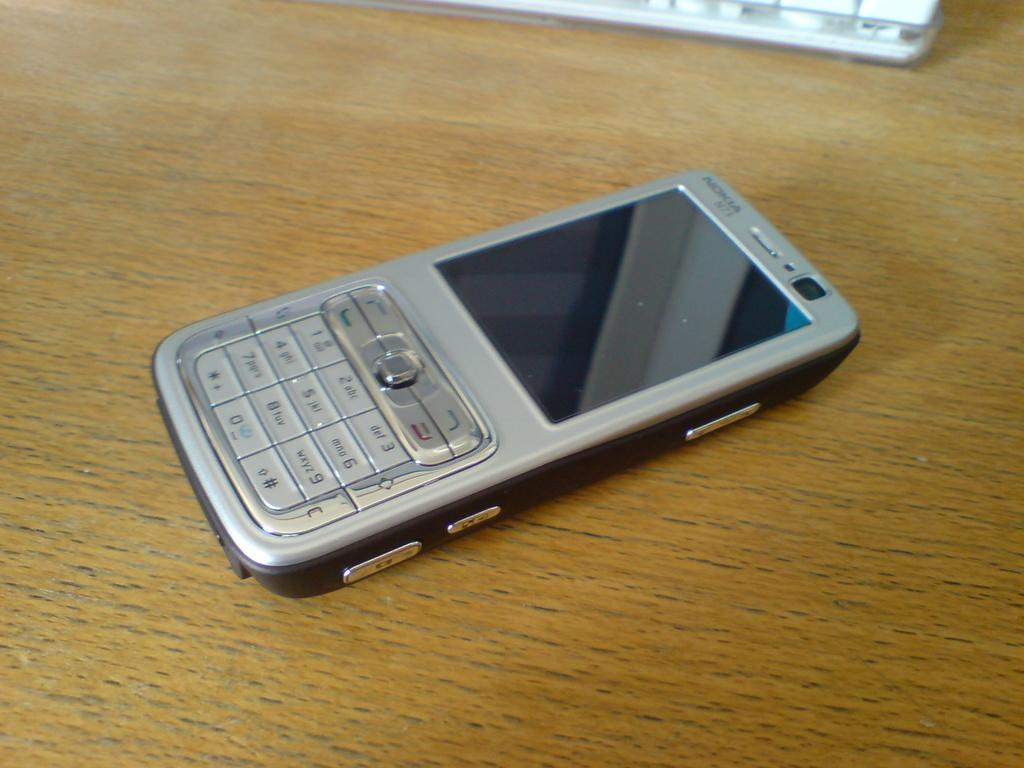<image>
Describe the image concisely. A silver Nokia phone sits on a wooden tabletop. 